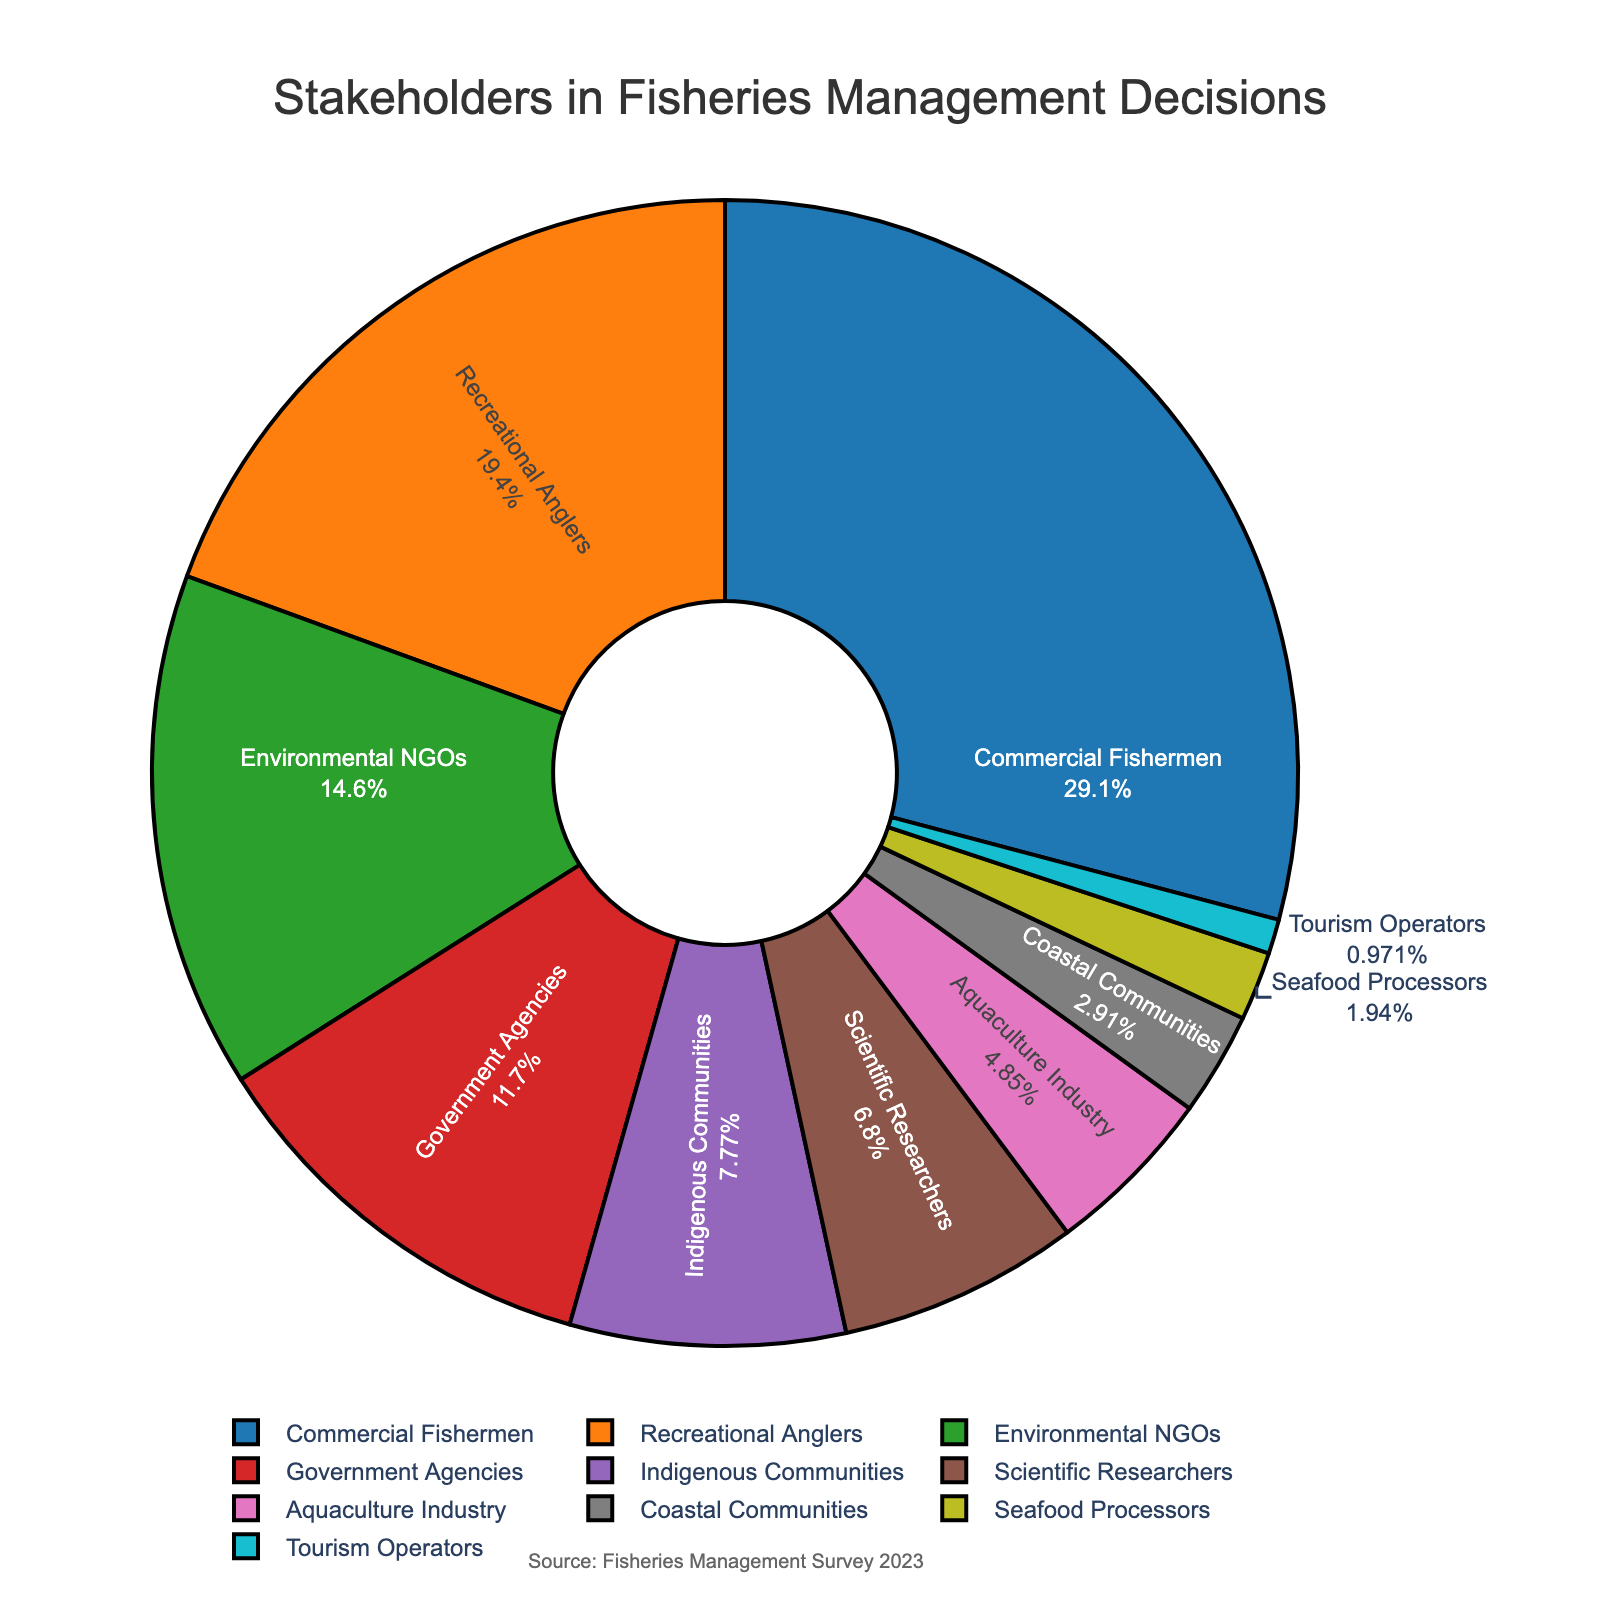Who are the two largest stakeholder groups in fisheries management decisions? The two largest stakeholder groups are those with the highest percentages on the pie chart. Commercial Fishermen have 30%, and Recreational Anglers have 20%.
Answer: Commercial Fishermen and Recreational Anglers What proportion of the stakeholders are made up by Indigenous Communities and Scientific Researchers together? Add the proportions for Indigenous Communities (8%) and Scientific Researchers (7%) from the pie chart. 8% + 7% = 15%
Answer: 15% Which stakeholder group has a slightly higher proportion than Indigenous Communities? The proportion for Indigenous Communities is 8%. The next higher proportion visible on the pie chart is 12% for Government Agencies.
Answer: Government Agencies By how much do Government Agencies exceed the Aquaculture Industry in proportion? Government Agencies have 12%, and Aquaculture Industry has 5%. The difference is 12% - 5% = 7%.
Answer: 7% Which stakeholder group represents the smallest proportion in fisheries management decisions? Identify the segment with the smallest percentage on the pie chart, which is 1% for Tourism Operators.
Answer: Tourism Operators How much larger is the proportion of Commercial Fishermen compared to Seafood Processors? Commercial Fishermen have a proportion of 30%, and Seafood Processors have 2%. Calculate the difference: 30% - 2% = 28%.
Answer: 28% What is the combined proportion of Coastal Communities and Tourism Operators? Add the proportions from the pie chart: Coastal Communities have 3% and Tourism Operators have 1%. The combined total is 3% + 1% = 4%.
Answer: 4% If you combine the proportions of Recreational Anglers and Environmental NGOs, what will be the result? Add the given proportions: Recreational Anglers (20%) and Environmental NGOs (15%). The result is 20% + 15% = 35%.
Answer: 35% Are there more Environmental NGOs or more Scientific Researchers involved in fisheries management decisions? Compare the percentages from the pie chart: Environmental NGOs have 15%, and Scientific Researchers have 7%. Environmental NGOs have a higher proportion.
Answer: Environmental NGOs What is the difference in proportion between the two smallest stakeholder groups? The smallest is Tourism Operators at 1%, and the next smallest is Seafood Processors at 2%. The difference is 2% - 1% = 1%.
Answer: 1% 